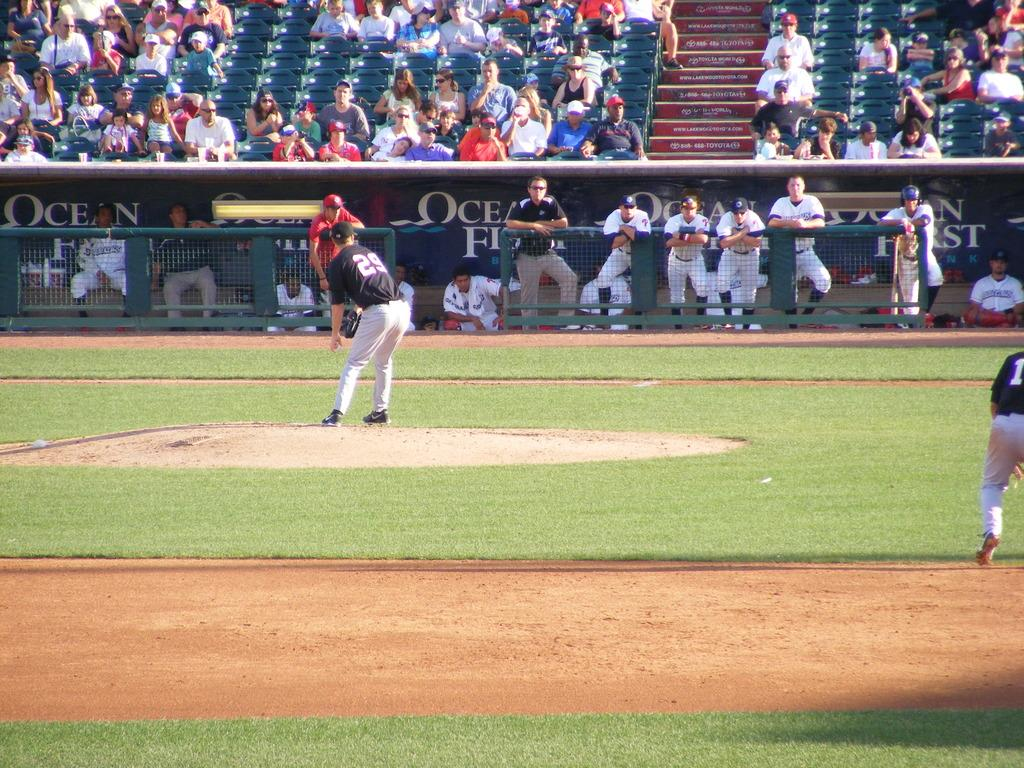<image>
Render a clear and concise summary of the photo. Baseball players sit in a dugout in front of the word Ocean. 